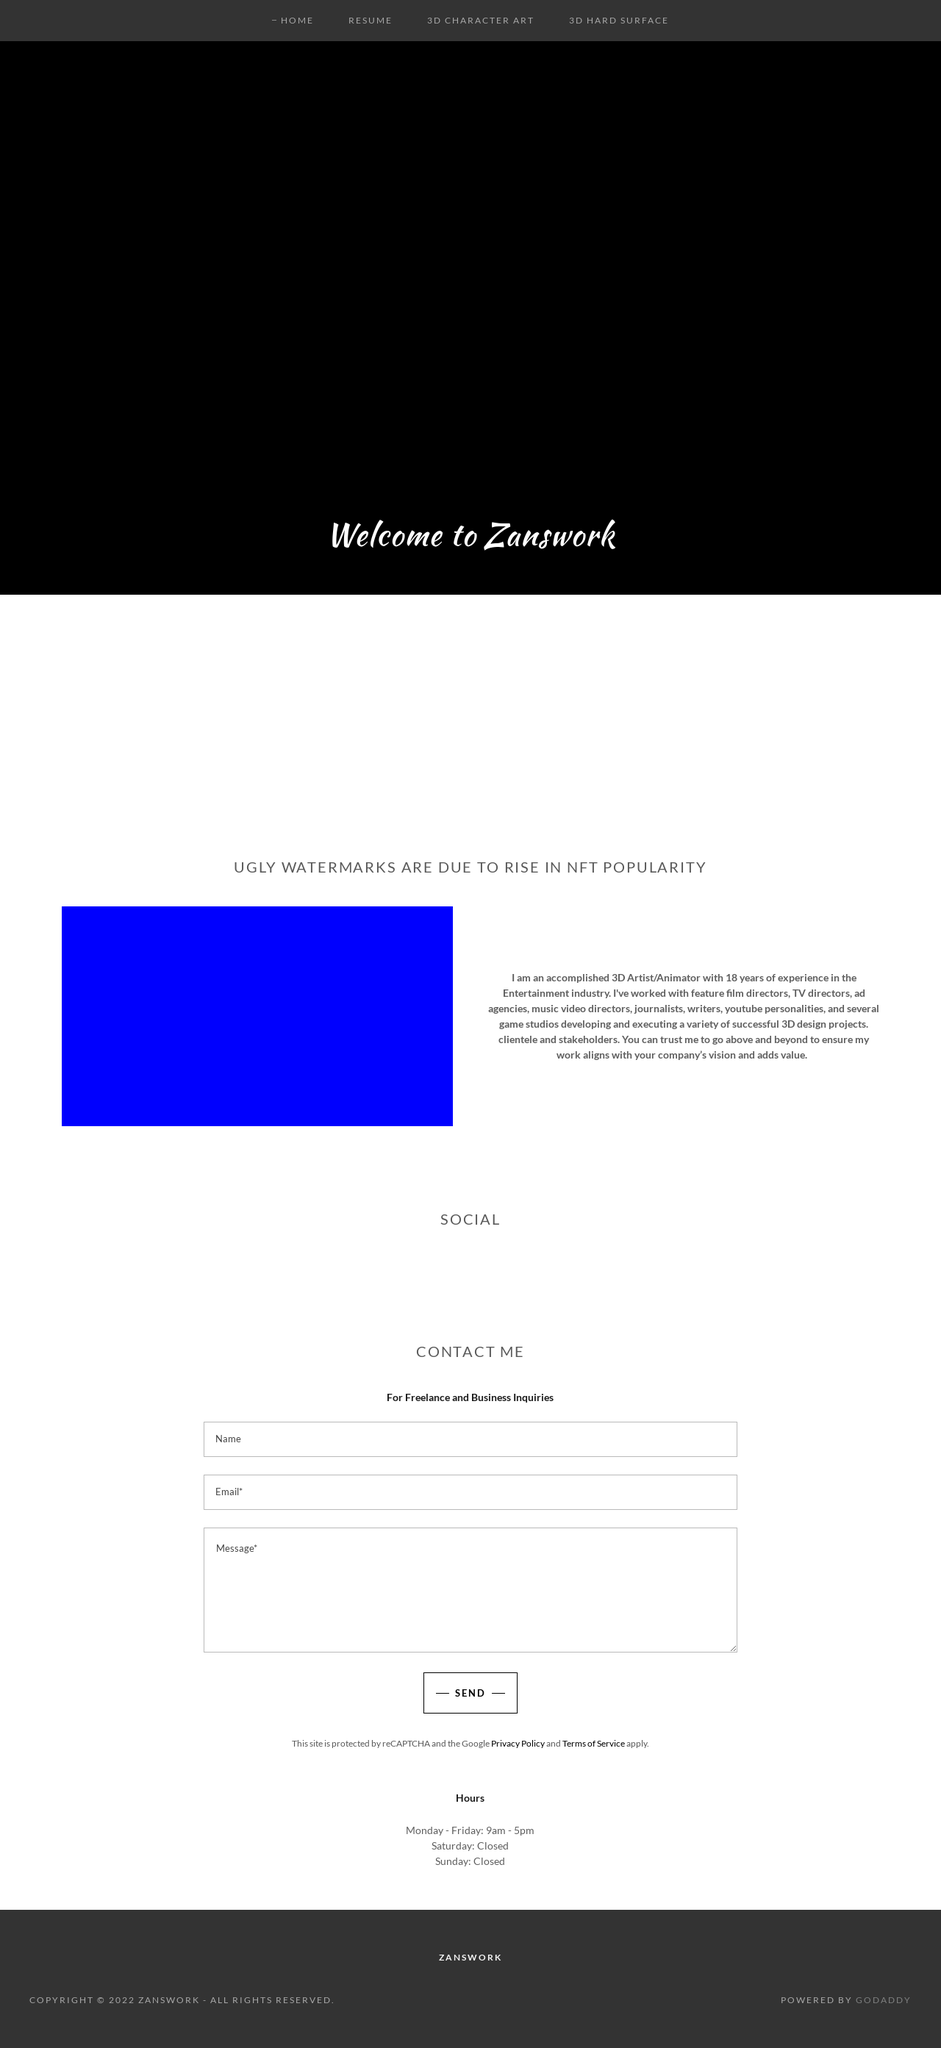Can you tell me more about the theme or the idea behind the minimalist design of the website showcased in this image? The minimalist design showcased in the image of the website reflects a modern and clean approach, focusing on usability and aesthetics. Minimalism in web design emphasizes the content and reduces visual clutter. This not only aids in faster loading times but also makes the site easier to navigate, ensuring that visitors can find the information they need without distraction. The use of ample white space, limited color palette, and straightforward typography highlight the professional nature of the site, which is crucial for a portfolio or a business website like Zanswork. What are some benefits of this design approach? Several benefits come with a minimalist web design approach. Firstly, it enhances user experience by providing a clear path to navigate, helping users interact with the website intuitively and efficiently. It also aids in the website’s SEO as less clutter means faster loading times, which is a significant factor in search engine ranking algorithms. Additionally, a minimalist design ensures the website looks good on various devices, from desktops to smartphones, making it highly responsive. Finally, it creates a professional image that can help build trust with visitors, essential for businesses and professionals who use their site as a digital portfolio. 